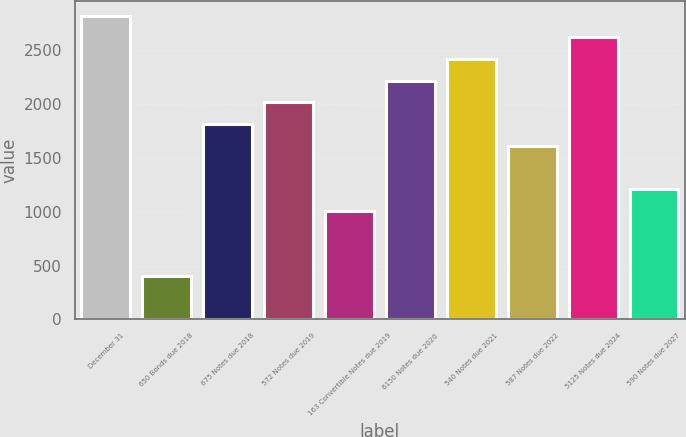<chart> <loc_0><loc_0><loc_500><loc_500><bar_chart><fcel>December 31<fcel>650 Bonds due 2018<fcel>675 Notes due 2018<fcel>572 Notes due 2019<fcel>163 Convertible Notes due 2019<fcel>6150 Notes due 2020<fcel>540 Notes due 2021<fcel>587 Notes due 2022<fcel>5125 Notes due 2024<fcel>590 Notes due 2027<nl><fcel>2820.8<fcel>406.4<fcel>1814.8<fcel>2016<fcel>1010<fcel>2217.2<fcel>2418.4<fcel>1613.6<fcel>2619.6<fcel>1211.2<nl></chart> 